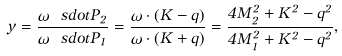<formula> <loc_0><loc_0><loc_500><loc_500>y = \frac { \omega \ s d o t P _ { 2 } } { \omega \ s d o t P _ { 1 } } = \frac { \omega \cdot ( K - q ) } { \omega \cdot ( K + q ) } = \frac { 4 M _ { 2 } ^ { 2 } + K ^ { 2 } - q ^ { 2 } } { 4 M _ { 1 } ^ { 2 } + K ^ { 2 } - q ^ { 2 } } ,</formula> 